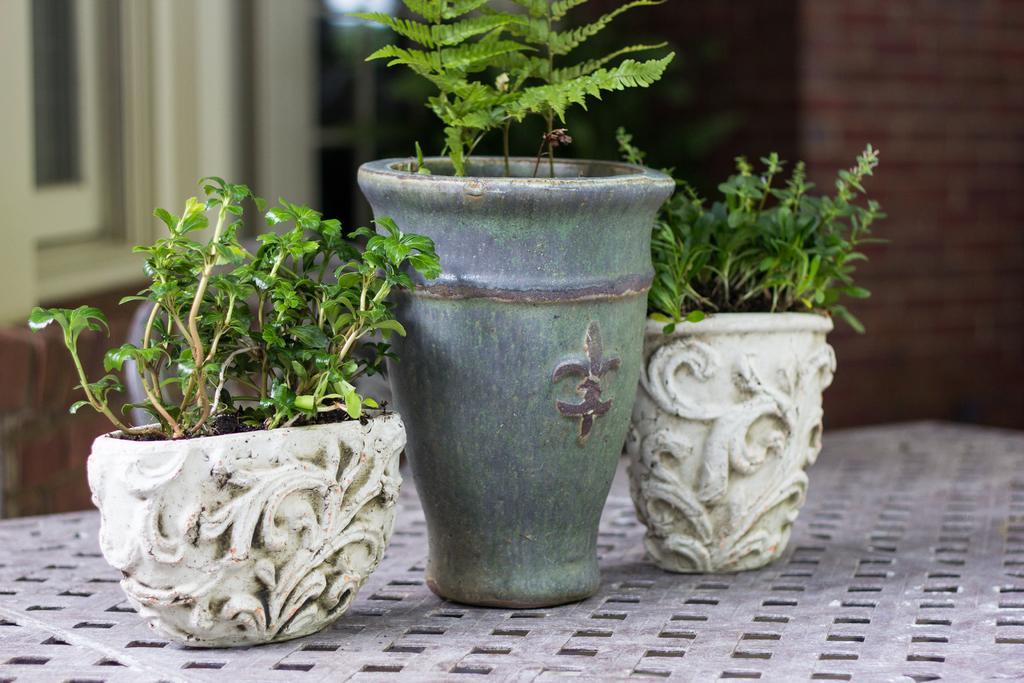Describe this image in one or two sentences. In this picture I can see there are three flower pots kept on the table and in the backdrop there is a building. 